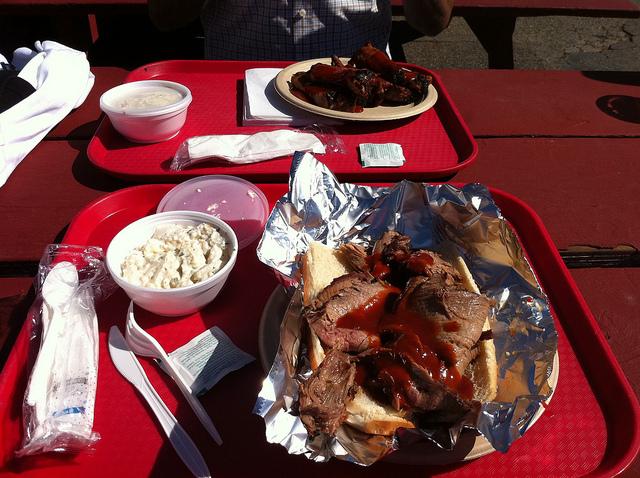What is on the tray?
Concise answer only. Food. Is the food setting indoors?
Answer briefly. No. Would a vegetarian eat this meal?
Quick response, please. No. Are these plastic trays?
Write a very short answer. Yes. 